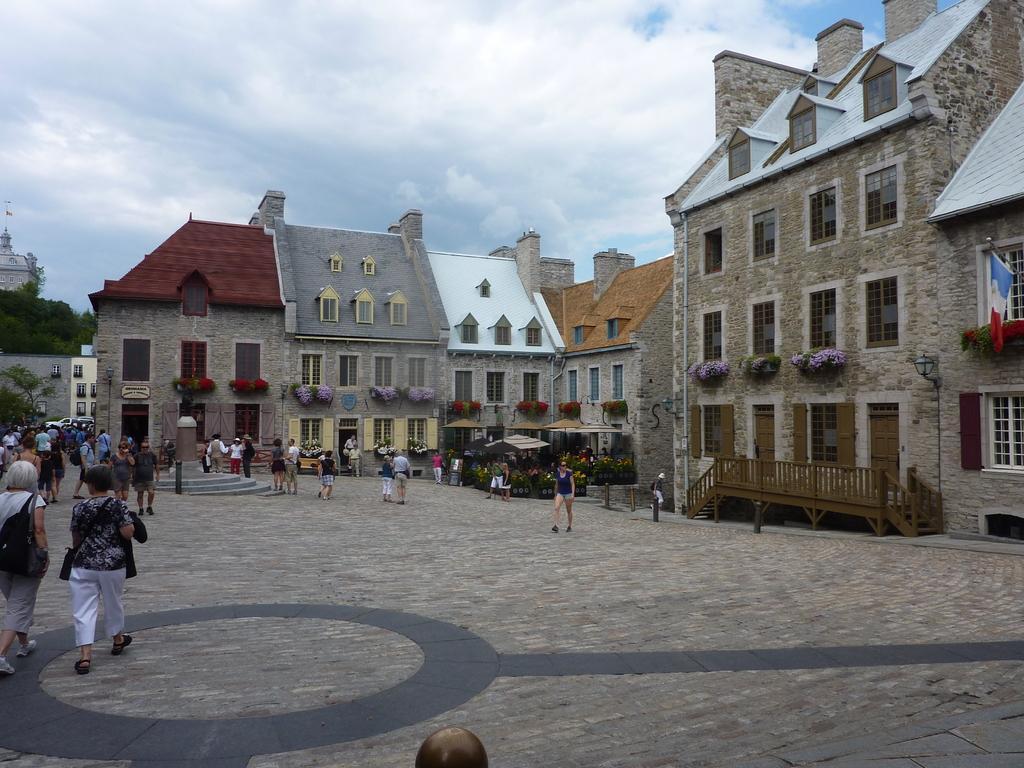How would you summarize this image in a sentence or two? In this given picture there are buildings with number of windows. And there are some people walking in front of these buildings. There is an open space here. There are some trees behind the building on the left side. And there are clouds all over the sky in the background. 